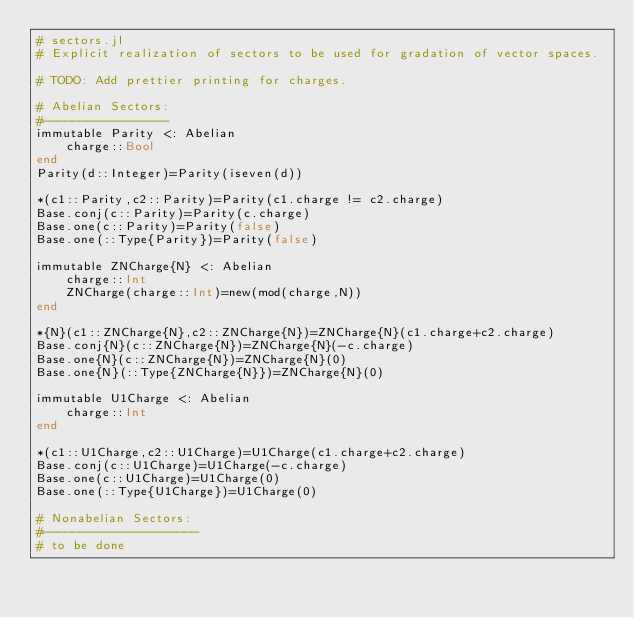Convert code to text. <code><loc_0><loc_0><loc_500><loc_500><_Julia_># sectors.jl
# Explicit realization of sectors to be used for gradation of vector spaces.

# TODO: Add prettier printing for charges.

# Abelian Sectors:
#-----------------
immutable Parity <: Abelian
    charge::Bool
end
Parity(d::Integer)=Parity(iseven(d))

*(c1::Parity,c2::Parity)=Parity(c1.charge != c2.charge)
Base.conj(c::Parity)=Parity(c.charge)
Base.one(c::Parity)=Parity(false)
Base.one(::Type{Parity})=Parity(false)

immutable ZNCharge{N} <: Abelian
    charge::Int
    ZNCharge(charge::Int)=new(mod(charge,N))
end

*{N}(c1::ZNCharge{N},c2::ZNCharge{N})=ZNCharge{N}(c1.charge+c2.charge)
Base.conj{N}(c::ZNCharge{N})=ZNCharge{N}(-c.charge)
Base.one{N}(c::ZNCharge{N})=ZNCharge{N}(0)
Base.one{N}(::Type{ZNCharge{N}})=ZNCharge{N}(0)

immutable U1Charge <: Abelian
    charge::Int
end

*(c1::U1Charge,c2::U1Charge)=U1Charge(c1.charge+c2.charge)
Base.conj(c::U1Charge)=U1Charge(-c.charge)
Base.one(c::U1Charge)=U1Charge(0)
Base.one(::Type{U1Charge})=U1Charge(0)

# Nonabelian Sectors:
#---------------------
# to be done
</code> 